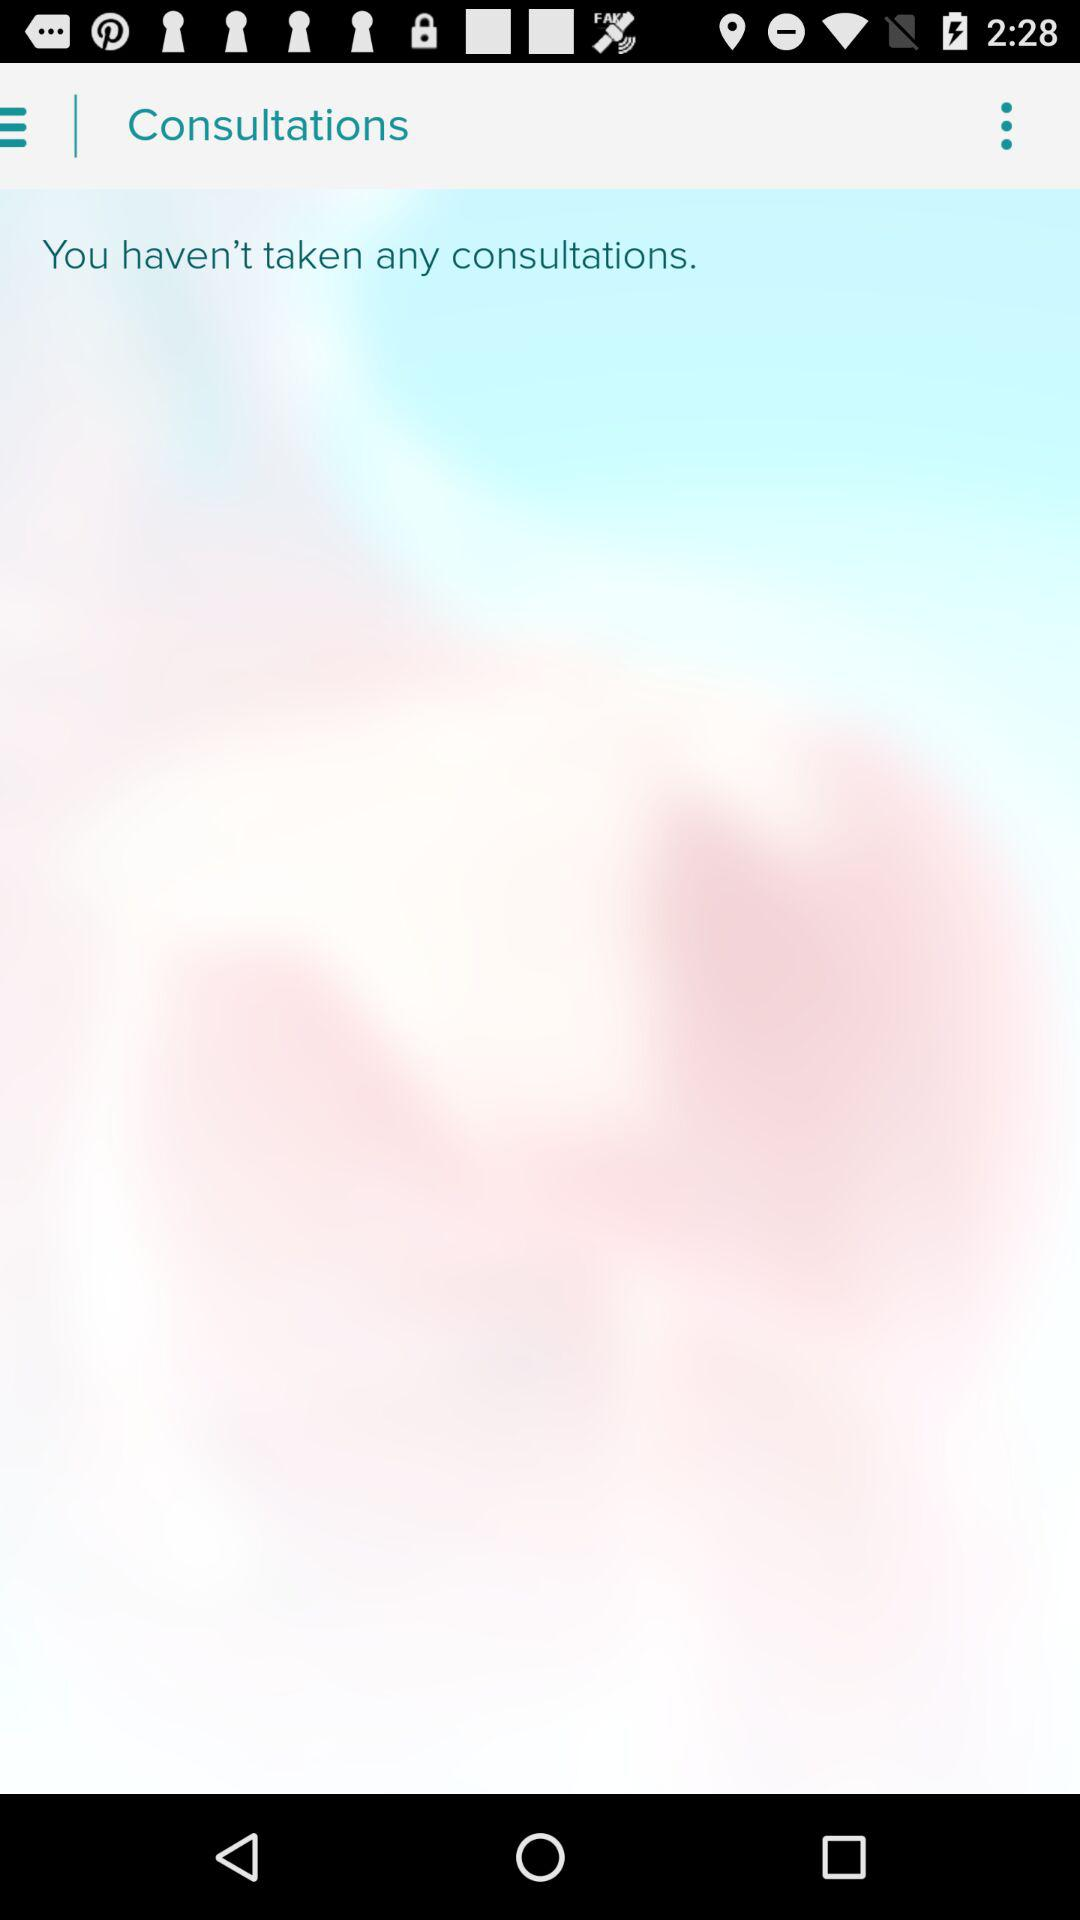Are there any consultations available? There are no consultations available. 